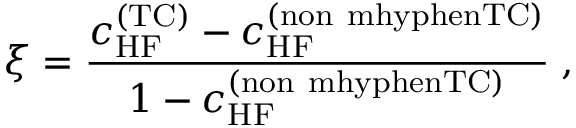<formula> <loc_0><loc_0><loc_500><loc_500>\xi = \frac { c _ { H F } ^ { ( T C ) } - c _ { H F } ^ { ( n o n \ m h y p h e n T C ) } } { 1 - c _ { H F } ^ { ( n o n \ m h y p h e n T C ) } } \, ,</formula> 